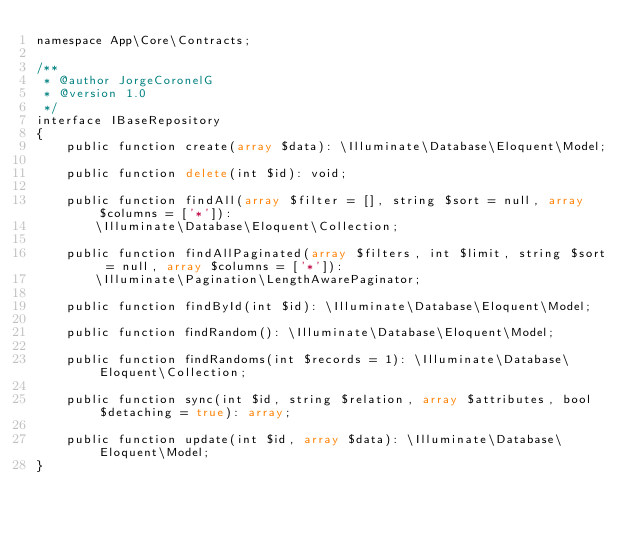Convert code to text. <code><loc_0><loc_0><loc_500><loc_500><_PHP_>namespace App\Core\Contracts;

/**
 * @author JorgeCoronelG
 * @version 1.0
 */
interface IBaseRepository
{
    public function create(array $data): \Illuminate\Database\Eloquent\Model;

    public function delete(int $id): void;

    public function findAll(array $filter = [], string $sort = null, array $columns = ['*']):
        \Illuminate\Database\Eloquent\Collection;

    public function findAllPaginated(array $filters, int $limit, string $sort = null, array $columns = ['*']):
        \Illuminate\Pagination\LengthAwarePaginator;

    public function findById(int $id): \Illuminate\Database\Eloquent\Model;

    public function findRandom(): \Illuminate\Database\Eloquent\Model;

    public function findRandoms(int $records = 1): \Illuminate\Database\Eloquent\Collection;

    public function sync(int $id, string $relation, array $attributes, bool $detaching = true): array;

    public function update(int $id, array $data): \Illuminate\Database\Eloquent\Model;
}
</code> 